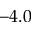Convert formula to latex. <formula><loc_0><loc_0><loc_500><loc_500>- 4 . 0</formula> 